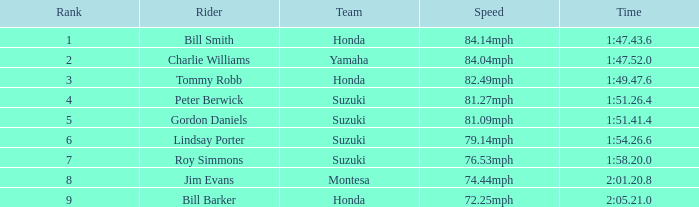Give me the full table as a dictionary. {'header': ['Rank', 'Rider', 'Team', 'Speed', 'Time'], 'rows': [['1', 'Bill Smith', 'Honda', '84.14mph', '1:47.43.6'], ['2', 'Charlie Williams', 'Yamaha', '84.04mph', '1:47.52.0'], ['3', 'Tommy Robb', 'Honda', '82.49mph', '1:49.47.6'], ['4', 'Peter Berwick', 'Suzuki', '81.27mph', '1:51.26.4'], ['5', 'Gordon Daniels', 'Suzuki', '81.09mph', '1:51.41.4'], ['6', 'Lindsay Porter', 'Suzuki', '79.14mph', '1:54.26.6'], ['7', 'Roy Simmons', 'Suzuki', '76.53mph', '1:58.20.0'], ['8', 'Jim Evans', 'Montesa', '74.44mph', '2:01.20.8'], ['9', 'Bill Barker', 'Honda', '72.25mph', '2:05.21.0']]} What was the time for Peter Berwick of Team Suzuki? 1:51.26.4. 